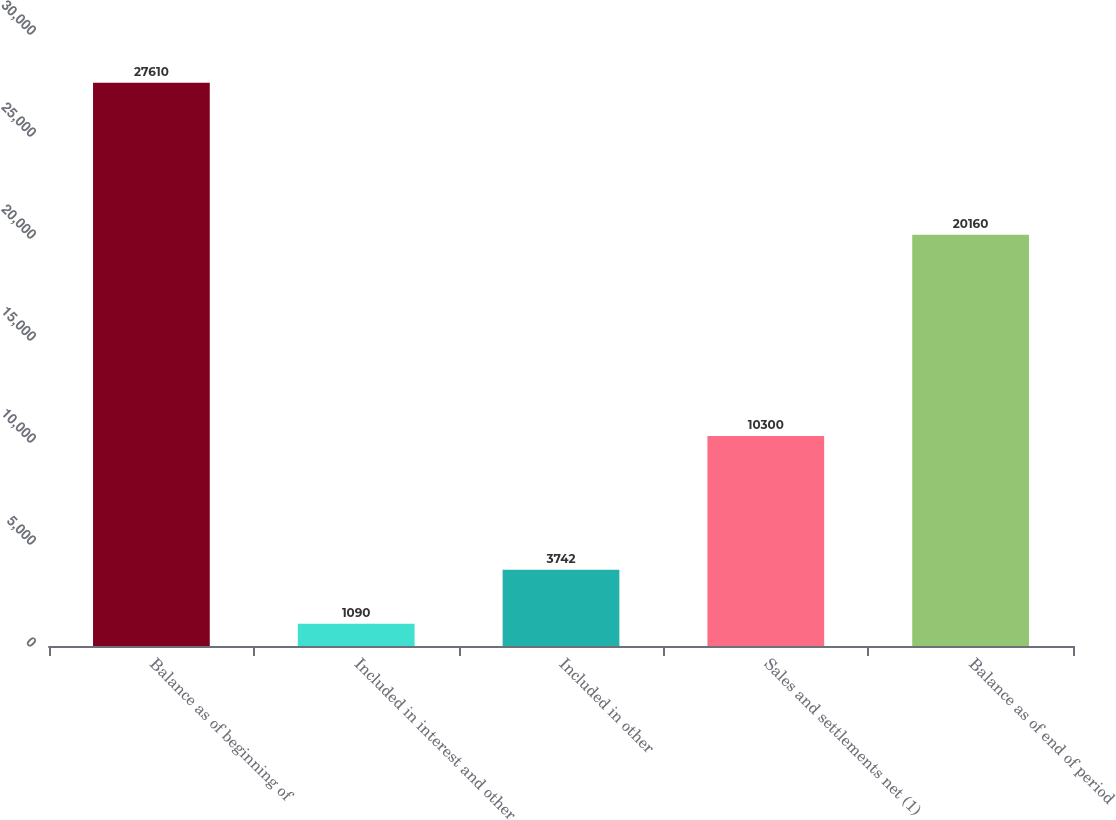Convert chart. <chart><loc_0><loc_0><loc_500><loc_500><bar_chart><fcel>Balance as of beginning of<fcel>Included in interest and other<fcel>Included in other<fcel>Sales and settlements net (1)<fcel>Balance as of end of period<nl><fcel>27610<fcel>1090<fcel>3742<fcel>10300<fcel>20160<nl></chart> 